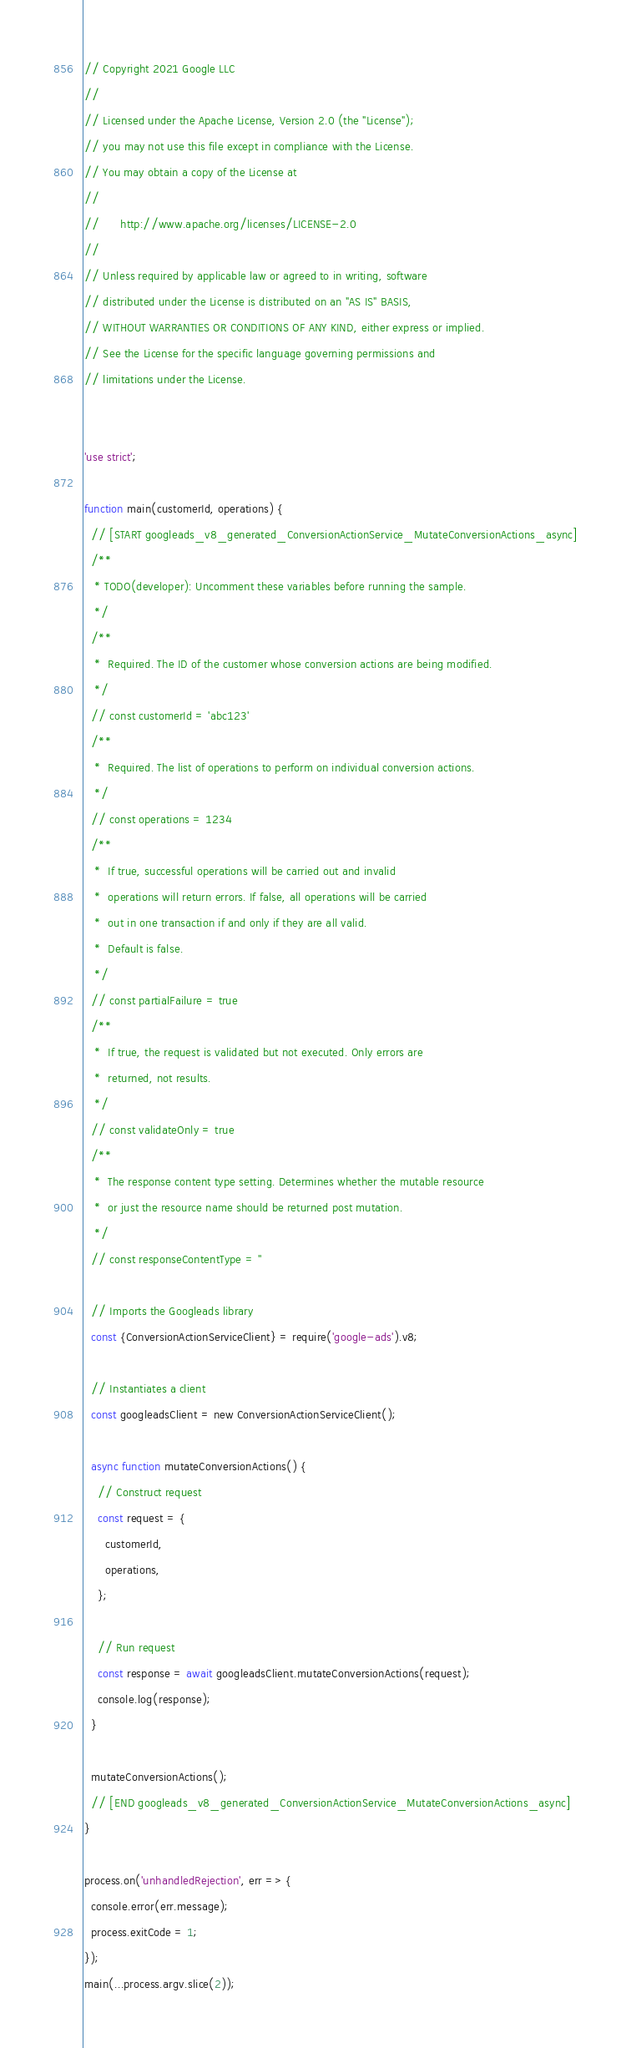<code> <loc_0><loc_0><loc_500><loc_500><_JavaScript_>// Copyright 2021 Google LLC
//
// Licensed under the Apache License, Version 2.0 (the "License");
// you may not use this file except in compliance with the License.
// You may obtain a copy of the License at
//
//      http://www.apache.org/licenses/LICENSE-2.0
//
// Unless required by applicable law or agreed to in writing, software
// distributed under the License is distributed on an "AS IS" BASIS,
// WITHOUT WARRANTIES OR CONDITIONS OF ANY KIND, either express or implied.
// See the License for the specific language governing permissions and
// limitations under the License.


'use strict';

function main(customerId, operations) {
  // [START googleads_v8_generated_ConversionActionService_MutateConversionActions_async]
  /**
   * TODO(developer): Uncomment these variables before running the sample.
   */
  /**
   *  Required. The ID of the customer whose conversion actions are being modified.
   */
  // const customerId = 'abc123'
  /**
   *  Required. The list of operations to perform on individual conversion actions.
   */
  // const operations = 1234
  /**
   *  If true, successful operations will be carried out and invalid
   *  operations will return errors. If false, all operations will be carried
   *  out in one transaction if and only if they are all valid.
   *  Default is false.
   */
  // const partialFailure = true
  /**
   *  If true, the request is validated but not executed. Only errors are
   *  returned, not results.
   */
  // const validateOnly = true
  /**
   *  The response content type setting. Determines whether the mutable resource
   *  or just the resource name should be returned post mutation.
   */
  // const responseContentType = ''

  // Imports the Googleads library
  const {ConversionActionServiceClient} = require('google-ads').v8;

  // Instantiates a client
  const googleadsClient = new ConversionActionServiceClient();

  async function mutateConversionActions() {
    // Construct request
    const request = {
      customerId,
      operations,
    };

    // Run request
    const response = await googleadsClient.mutateConversionActions(request);
    console.log(response);
  }

  mutateConversionActions();
  // [END googleads_v8_generated_ConversionActionService_MutateConversionActions_async]
}

process.on('unhandledRejection', err => {
  console.error(err.message);
  process.exitCode = 1;
});
main(...process.argv.slice(2));
</code> 